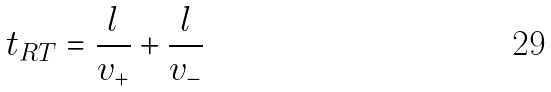Convert formula to latex. <formula><loc_0><loc_0><loc_500><loc_500>t _ { R T } = \frac { l } { v _ { + } } + \frac { l } { v _ { - } }</formula> 